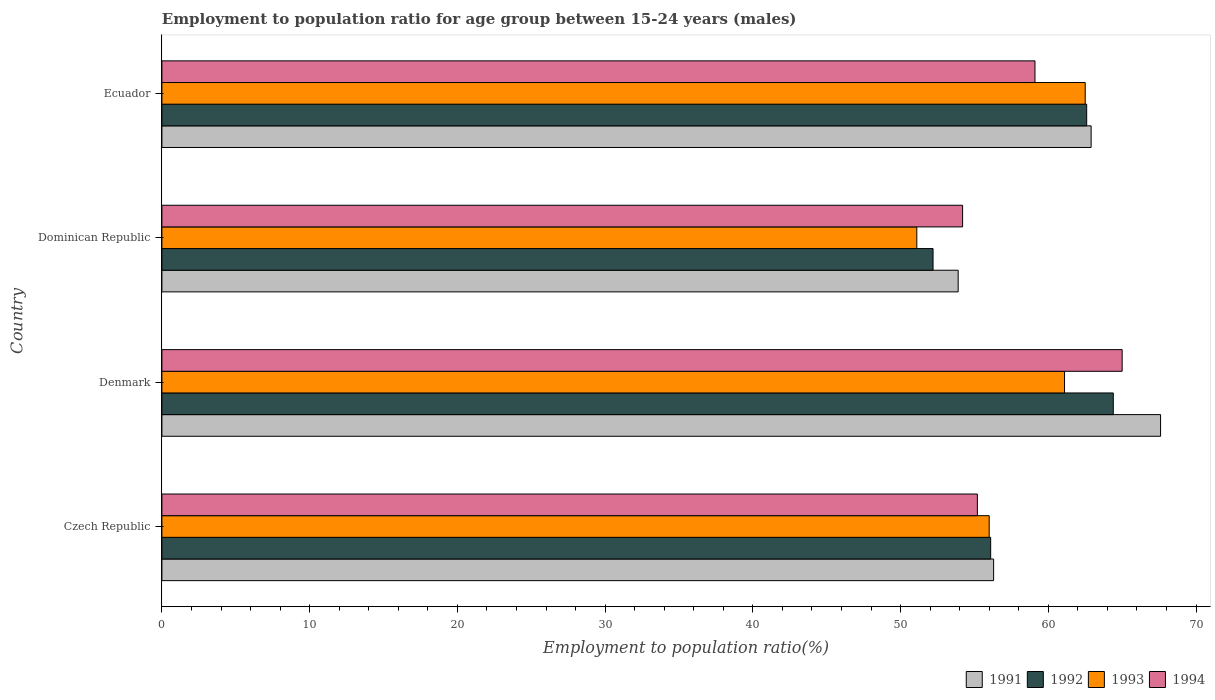Are the number of bars on each tick of the Y-axis equal?
Make the answer very short. Yes. In how many cases, is the number of bars for a given country not equal to the number of legend labels?
Provide a succinct answer. 0. What is the employment to population ratio in 1991 in Czech Republic?
Provide a succinct answer. 56.3. Across all countries, what is the maximum employment to population ratio in 1992?
Your answer should be very brief. 64.4. Across all countries, what is the minimum employment to population ratio in 1994?
Provide a short and direct response. 54.2. In which country was the employment to population ratio in 1994 maximum?
Give a very brief answer. Denmark. In which country was the employment to population ratio in 1992 minimum?
Provide a short and direct response. Dominican Republic. What is the total employment to population ratio in 1994 in the graph?
Provide a succinct answer. 233.5. What is the difference between the employment to population ratio in 1992 in Czech Republic and that in Denmark?
Your response must be concise. -8.3. What is the difference between the employment to population ratio in 1993 in Czech Republic and the employment to population ratio in 1991 in Denmark?
Ensure brevity in your answer.  -11.6. What is the average employment to population ratio in 1993 per country?
Provide a short and direct response. 57.67. What is the difference between the employment to population ratio in 1992 and employment to population ratio in 1991 in Dominican Republic?
Keep it short and to the point. -1.7. In how many countries, is the employment to population ratio in 1992 greater than 50 %?
Offer a terse response. 4. What is the ratio of the employment to population ratio in 1994 in Denmark to that in Dominican Republic?
Provide a short and direct response. 1.2. Is the employment to population ratio in 1994 in Czech Republic less than that in Dominican Republic?
Your answer should be very brief. No. What is the difference between the highest and the second highest employment to population ratio in 1993?
Provide a succinct answer. 1.4. What is the difference between the highest and the lowest employment to population ratio in 1993?
Make the answer very short. 11.4. Is the sum of the employment to population ratio in 1992 in Czech Republic and Ecuador greater than the maximum employment to population ratio in 1994 across all countries?
Your answer should be compact. Yes. What does the 3rd bar from the bottom in Dominican Republic represents?
Give a very brief answer. 1993. How many bars are there?
Your response must be concise. 16. Are all the bars in the graph horizontal?
Your answer should be very brief. Yes. Where does the legend appear in the graph?
Keep it short and to the point. Bottom right. What is the title of the graph?
Your response must be concise. Employment to population ratio for age group between 15-24 years (males). Does "2009" appear as one of the legend labels in the graph?
Your answer should be compact. No. What is the Employment to population ratio(%) in 1991 in Czech Republic?
Provide a succinct answer. 56.3. What is the Employment to population ratio(%) in 1992 in Czech Republic?
Provide a short and direct response. 56.1. What is the Employment to population ratio(%) in 1994 in Czech Republic?
Your answer should be compact. 55.2. What is the Employment to population ratio(%) of 1991 in Denmark?
Keep it short and to the point. 67.6. What is the Employment to population ratio(%) of 1992 in Denmark?
Make the answer very short. 64.4. What is the Employment to population ratio(%) of 1993 in Denmark?
Offer a very short reply. 61.1. What is the Employment to population ratio(%) in 1991 in Dominican Republic?
Make the answer very short. 53.9. What is the Employment to population ratio(%) of 1992 in Dominican Republic?
Offer a terse response. 52.2. What is the Employment to population ratio(%) of 1993 in Dominican Republic?
Provide a short and direct response. 51.1. What is the Employment to population ratio(%) of 1994 in Dominican Republic?
Give a very brief answer. 54.2. What is the Employment to population ratio(%) in 1991 in Ecuador?
Ensure brevity in your answer.  62.9. What is the Employment to population ratio(%) of 1992 in Ecuador?
Your answer should be compact. 62.6. What is the Employment to population ratio(%) of 1993 in Ecuador?
Provide a short and direct response. 62.5. What is the Employment to population ratio(%) in 1994 in Ecuador?
Make the answer very short. 59.1. Across all countries, what is the maximum Employment to population ratio(%) of 1991?
Your response must be concise. 67.6. Across all countries, what is the maximum Employment to population ratio(%) in 1992?
Offer a very short reply. 64.4. Across all countries, what is the maximum Employment to population ratio(%) of 1993?
Make the answer very short. 62.5. Across all countries, what is the maximum Employment to population ratio(%) of 1994?
Your answer should be very brief. 65. Across all countries, what is the minimum Employment to population ratio(%) of 1991?
Your answer should be very brief. 53.9. Across all countries, what is the minimum Employment to population ratio(%) of 1992?
Keep it short and to the point. 52.2. Across all countries, what is the minimum Employment to population ratio(%) of 1993?
Your answer should be very brief. 51.1. Across all countries, what is the minimum Employment to population ratio(%) of 1994?
Keep it short and to the point. 54.2. What is the total Employment to population ratio(%) of 1991 in the graph?
Offer a very short reply. 240.7. What is the total Employment to population ratio(%) of 1992 in the graph?
Your response must be concise. 235.3. What is the total Employment to population ratio(%) of 1993 in the graph?
Your response must be concise. 230.7. What is the total Employment to population ratio(%) of 1994 in the graph?
Make the answer very short. 233.5. What is the difference between the Employment to population ratio(%) of 1991 in Czech Republic and that in Denmark?
Offer a terse response. -11.3. What is the difference between the Employment to population ratio(%) in 1992 in Czech Republic and that in Denmark?
Provide a succinct answer. -8.3. What is the difference between the Employment to population ratio(%) of 1993 in Czech Republic and that in Denmark?
Provide a succinct answer. -5.1. What is the difference between the Employment to population ratio(%) in 1994 in Czech Republic and that in Denmark?
Ensure brevity in your answer.  -9.8. What is the difference between the Employment to population ratio(%) of 1992 in Czech Republic and that in Dominican Republic?
Your answer should be very brief. 3.9. What is the difference between the Employment to population ratio(%) in 1993 in Czech Republic and that in Dominican Republic?
Your response must be concise. 4.9. What is the difference between the Employment to population ratio(%) of 1994 in Czech Republic and that in Dominican Republic?
Provide a short and direct response. 1. What is the difference between the Employment to population ratio(%) of 1991 in Czech Republic and that in Ecuador?
Your answer should be very brief. -6.6. What is the difference between the Employment to population ratio(%) of 1993 in Czech Republic and that in Ecuador?
Offer a very short reply. -6.5. What is the difference between the Employment to population ratio(%) in 1991 in Denmark and that in Dominican Republic?
Make the answer very short. 13.7. What is the difference between the Employment to population ratio(%) of 1992 in Denmark and that in Dominican Republic?
Provide a succinct answer. 12.2. What is the difference between the Employment to population ratio(%) of 1993 in Denmark and that in Dominican Republic?
Your response must be concise. 10. What is the difference between the Employment to population ratio(%) of 1991 in Denmark and that in Ecuador?
Give a very brief answer. 4.7. What is the difference between the Employment to population ratio(%) in 1992 in Denmark and that in Ecuador?
Give a very brief answer. 1.8. What is the difference between the Employment to population ratio(%) in 1993 in Denmark and that in Ecuador?
Keep it short and to the point. -1.4. What is the difference between the Employment to population ratio(%) of 1994 in Denmark and that in Ecuador?
Offer a terse response. 5.9. What is the difference between the Employment to population ratio(%) of 1991 in Dominican Republic and that in Ecuador?
Ensure brevity in your answer.  -9. What is the difference between the Employment to population ratio(%) of 1992 in Dominican Republic and that in Ecuador?
Keep it short and to the point. -10.4. What is the difference between the Employment to population ratio(%) in 1991 in Czech Republic and the Employment to population ratio(%) in 1993 in Denmark?
Give a very brief answer. -4.8. What is the difference between the Employment to population ratio(%) in 1991 in Czech Republic and the Employment to population ratio(%) in 1994 in Denmark?
Give a very brief answer. -8.7. What is the difference between the Employment to population ratio(%) of 1992 in Czech Republic and the Employment to population ratio(%) of 1993 in Denmark?
Keep it short and to the point. -5. What is the difference between the Employment to population ratio(%) in 1992 in Czech Republic and the Employment to population ratio(%) in 1994 in Denmark?
Ensure brevity in your answer.  -8.9. What is the difference between the Employment to population ratio(%) of 1991 in Czech Republic and the Employment to population ratio(%) of 1992 in Dominican Republic?
Give a very brief answer. 4.1. What is the difference between the Employment to population ratio(%) in 1992 in Czech Republic and the Employment to population ratio(%) in 1994 in Dominican Republic?
Your response must be concise. 1.9. What is the difference between the Employment to population ratio(%) of 1993 in Czech Republic and the Employment to population ratio(%) of 1994 in Dominican Republic?
Keep it short and to the point. 1.8. What is the difference between the Employment to population ratio(%) of 1991 in Czech Republic and the Employment to population ratio(%) of 1992 in Ecuador?
Your answer should be very brief. -6.3. What is the difference between the Employment to population ratio(%) in 1991 in Czech Republic and the Employment to population ratio(%) in 1994 in Ecuador?
Give a very brief answer. -2.8. What is the difference between the Employment to population ratio(%) in 1992 in Czech Republic and the Employment to population ratio(%) in 1994 in Ecuador?
Your response must be concise. -3. What is the difference between the Employment to population ratio(%) of 1993 in Czech Republic and the Employment to population ratio(%) of 1994 in Ecuador?
Provide a succinct answer. -3.1. What is the difference between the Employment to population ratio(%) of 1991 in Denmark and the Employment to population ratio(%) of 1992 in Dominican Republic?
Keep it short and to the point. 15.4. What is the difference between the Employment to population ratio(%) of 1991 in Denmark and the Employment to population ratio(%) of 1994 in Dominican Republic?
Your answer should be compact. 13.4. What is the difference between the Employment to population ratio(%) in 1992 in Denmark and the Employment to population ratio(%) in 1994 in Dominican Republic?
Offer a very short reply. 10.2. What is the difference between the Employment to population ratio(%) of 1993 in Denmark and the Employment to population ratio(%) of 1994 in Dominican Republic?
Your answer should be compact. 6.9. What is the difference between the Employment to population ratio(%) of 1992 in Denmark and the Employment to population ratio(%) of 1994 in Ecuador?
Your answer should be compact. 5.3. What is the difference between the Employment to population ratio(%) of 1991 in Dominican Republic and the Employment to population ratio(%) of 1992 in Ecuador?
Ensure brevity in your answer.  -8.7. What is the difference between the Employment to population ratio(%) of 1991 in Dominican Republic and the Employment to population ratio(%) of 1993 in Ecuador?
Offer a very short reply. -8.6. What is the difference between the Employment to population ratio(%) of 1991 in Dominican Republic and the Employment to population ratio(%) of 1994 in Ecuador?
Provide a succinct answer. -5.2. What is the difference between the Employment to population ratio(%) in 1992 in Dominican Republic and the Employment to population ratio(%) in 1994 in Ecuador?
Your answer should be compact. -6.9. What is the difference between the Employment to population ratio(%) in 1993 in Dominican Republic and the Employment to population ratio(%) in 1994 in Ecuador?
Provide a short and direct response. -8. What is the average Employment to population ratio(%) in 1991 per country?
Give a very brief answer. 60.17. What is the average Employment to population ratio(%) of 1992 per country?
Offer a terse response. 58.83. What is the average Employment to population ratio(%) in 1993 per country?
Give a very brief answer. 57.67. What is the average Employment to population ratio(%) of 1994 per country?
Make the answer very short. 58.38. What is the difference between the Employment to population ratio(%) in 1991 and Employment to population ratio(%) in 1992 in Czech Republic?
Provide a succinct answer. 0.2. What is the difference between the Employment to population ratio(%) in 1991 and Employment to population ratio(%) in 1993 in Czech Republic?
Offer a terse response. 0.3. What is the difference between the Employment to population ratio(%) in 1992 and Employment to population ratio(%) in 1993 in Czech Republic?
Make the answer very short. 0.1. What is the difference between the Employment to population ratio(%) of 1991 and Employment to population ratio(%) of 1992 in Denmark?
Your answer should be compact. 3.2. What is the difference between the Employment to population ratio(%) in 1991 and Employment to population ratio(%) in 1994 in Denmark?
Keep it short and to the point. 2.6. What is the difference between the Employment to population ratio(%) in 1992 and Employment to population ratio(%) in 1993 in Denmark?
Your answer should be compact. 3.3. What is the difference between the Employment to population ratio(%) in 1992 and Employment to population ratio(%) in 1994 in Denmark?
Keep it short and to the point. -0.6. What is the difference between the Employment to population ratio(%) of 1991 and Employment to population ratio(%) of 1992 in Dominican Republic?
Your answer should be compact. 1.7. What is the difference between the Employment to population ratio(%) of 1991 and Employment to population ratio(%) of 1993 in Dominican Republic?
Your answer should be very brief. 2.8. What is the difference between the Employment to population ratio(%) in 1991 and Employment to population ratio(%) in 1994 in Dominican Republic?
Give a very brief answer. -0.3. What is the difference between the Employment to population ratio(%) of 1992 and Employment to population ratio(%) of 1993 in Dominican Republic?
Make the answer very short. 1.1. What is the difference between the Employment to population ratio(%) in 1991 and Employment to population ratio(%) in 1992 in Ecuador?
Your answer should be compact. 0.3. What is the difference between the Employment to population ratio(%) of 1991 and Employment to population ratio(%) of 1993 in Ecuador?
Give a very brief answer. 0.4. What is the difference between the Employment to population ratio(%) of 1991 and Employment to population ratio(%) of 1994 in Ecuador?
Make the answer very short. 3.8. What is the difference between the Employment to population ratio(%) of 1992 and Employment to population ratio(%) of 1993 in Ecuador?
Offer a very short reply. 0.1. What is the ratio of the Employment to population ratio(%) of 1991 in Czech Republic to that in Denmark?
Your response must be concise. 0.83. What is the ratio of the Employment to population ratio(%) in 1992 in Czech Republic to that in Denmark?
Your answer should be very brief. 0.87. What is the ratio of the Employment to population ratio(%) of 1993 in Czech Republic to that in Denmark?
Give a very brief answer. 0.92. What is the ratio of the Employment to population ratio(%) of 1994 in Czech Republic to that in Denmark?
Your answer should be very brief. 0.85. What is the ratio of the Employment to population ratio(%) in 1991 in Czech Republic to that in Dominican Republic?
Your answer should be compact. 1.04. What is the ratio of the Employment to population ratio(%) in 1992 in Czech Republic to that in Dominican Republic?
Provide a succinct answer. 1.07. What is the ratio of the Employment to population ratio(%) of 1993 in Czech Republic to that in Dominican Republic?
Give a very brief answer. 1.1. What is the ratio of the Employment to population ratio(%) in 1994 in Czech Republic to that in Dominican Republic?
Make the answer very short. 1.02. What is the ratio of the Employment to population ratio(%) of 1991 in Czech Republic to that in Ecuador?
Offer a terse response. 0.9. What is the ratio of the Employment to population ratio(%) of 1992 in Czech Republic to that in Ecuador?
Provide a short and direct response. 0.9. What is the ratio of the Employment to population ratio(%) of 1993 in Czech Republic to that in Ecuador?
Make the answer very short. 0.9. What is the ratio of the Employment to population ratio(%) in 1994 in Czech Republic to that in Ecuador?
Make the answer very short. 0.93. What is the ratio of the Employment to population ratio(%) of 1991 in Denmark to that in Dominican Republic?
Your response must be concise. 1.25. What is the ratio of the Employment to population ratio(%) in 1992 in Denmark to that in Dominican Republic?
Give a very brief answer. 1.23. What is the ratio of the Employment to population ratio(%) in 1993 in Denmark to that in Dominican Republic?
Provide a short and direct response. 1.2. What is the ratio of the Employment to population ratio(%) in 1994 in Denmark to that in Dominican Republic?
Provide a succinct answer. 1.2. What is the ratio of the Employment to population ratio(%) in 1991 in Denmark to that in Ecuador?
Give a very brief answer. 1.07. What is the ratio of the Employment to population ratio(%) of 1992 in Denmark to that in Ecuador?
Provide a short and direct response. 1.03. What is the ratio of the Employment to population ratio(%) in 1993 in Denmark to that in Ecuador?
Provide a succinct answer. 0.98. What is the ratio of the Employment to population ratio(%) in 1994 in Denmark to that in Ecuador?
Ensure brevity in your answer.  1.1. What is the ratio of the Employment to population ratio(%) in 1991 in Dominican Republic to that in Ecuador?
Provide a succinct answer. 0.86. What is the ratio of the Employment to population ratio(%) in 1992 in Dominican Republic to that in Ecuador?
Your response must be concise. 0.83. What is the ratio of the Employment to population ratio(%) in 1993 in Dominican Republic to that in Ecuador?
Your answer should be compact. 0.82. What is the ratio of the Employment to population ratio(%) in 1994 in Dominican Republic to that in Ecuador?
Provide a short and direct response. 0.92. What is the difference between the highest and the second highest Employment to population ratio(%) of 1991?
Provide a short and direct response. 4.7. What is the difference between the highest and the second highest Employment to population ratio(%) in 1993?
Your answer should be very brief. 1.4. What is the difference between the highest and the lowest Employment to population ratio(%) in 1993?
Provide a short and direct response. 11.4. 